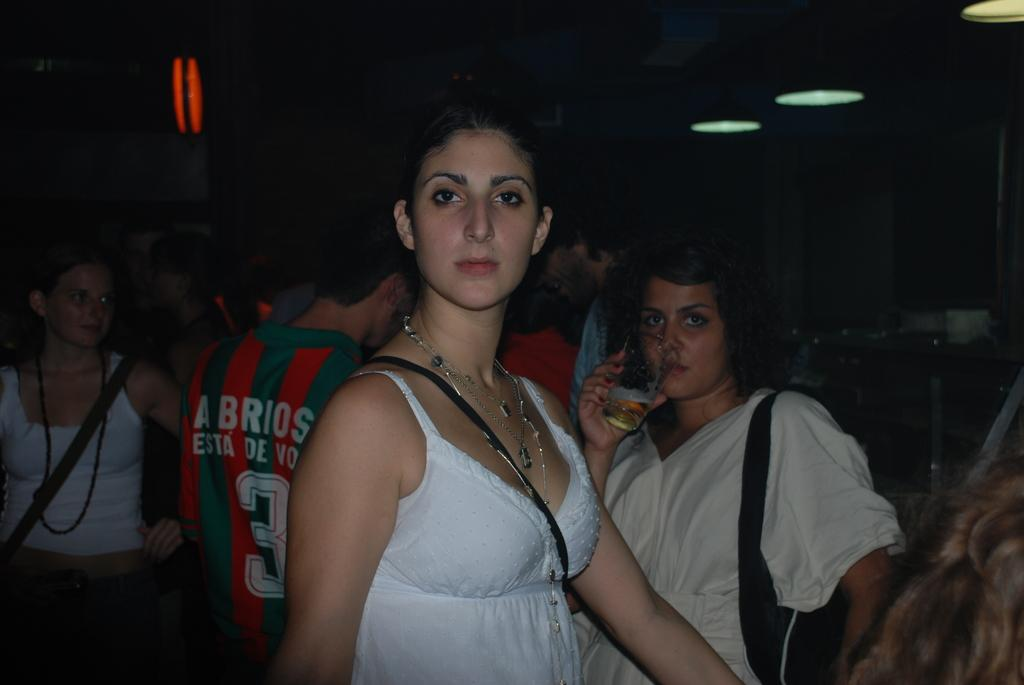How many people are in the image? There is a group of people in the image, but the exact number is not specified. What is the person holding in the image? The person is holding a glass. What can be seen in the image that provides illumination? There are lights visible in the image. What else can be seen in the image besides the people and the glass? There are other objects in the image. What is the color of the background in the image? The background of the image is dark. How many boats are visible in the image? There are no boats present in the image. What type of chalk is being used to draw on the wall in the image? There is no chalk or drawing on the wall in the image. 